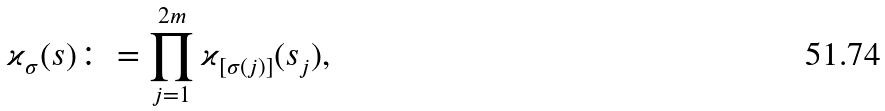<formula> <loc_0><loc_0><loc_500><loc_500>\varkappa _ { \sigma } ( s ) \colon = \prod _ { j = 1 } ^ { 2 m } \varkappa _ { [ \sigma ( j ) ] } ( s _ { j } ) ,</formula> 